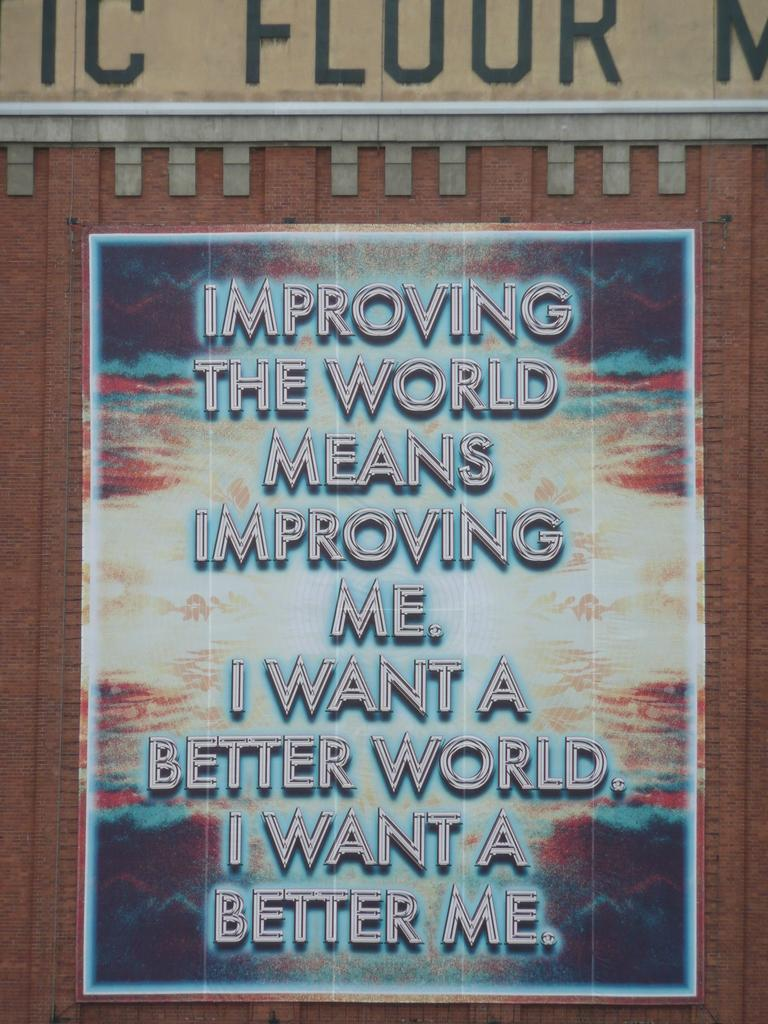Provide a one-sentence caption for the provided image. A poster displays the text 'IMPROVING THE WORLD MEANS IMPROVING ME'. 